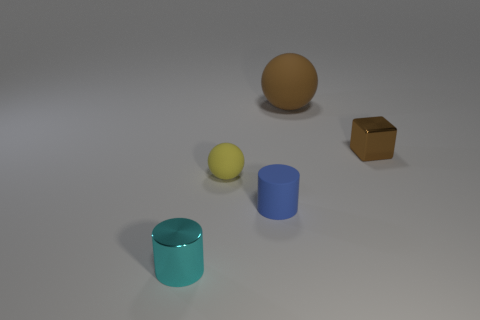Is there any other thing that has the same size as the brown matte sphere?
Keep it short and to the point. No. What number of brown matte spheres have the same size as the blue thing?
Your answer should be compact. 0. What number of blue things are either small matte objects or large things?
Offer a very short reply. 1. Is the number of large things that are on the left side of the tiny blue rubber object the same as the number of blue rubber objects?
Offer a very short reply. No. There is a thing in front of the small blue cylinder; how big is it?
Make the answer very short. Small. How many big gray metal objects are the same shape as the big matte thing?
Keep it short and to the point. 0. There is a tiny object that is behind the tiny blue rubber cylinder and to the left of the small metal cube; what is its material?
Ensure brevity in your answer.  Rubber. Is the material of the small brown object the same as the cyan cylinder?
Provide a succinct answer. Yes. What number of small cyan cylinders are there?
Ensure brevity in your answer.  1. The matte thing behind the matte ball in front of the small metal object right of the cyan shiny cylinder is what color?
Offer a very short reply. Brown. 